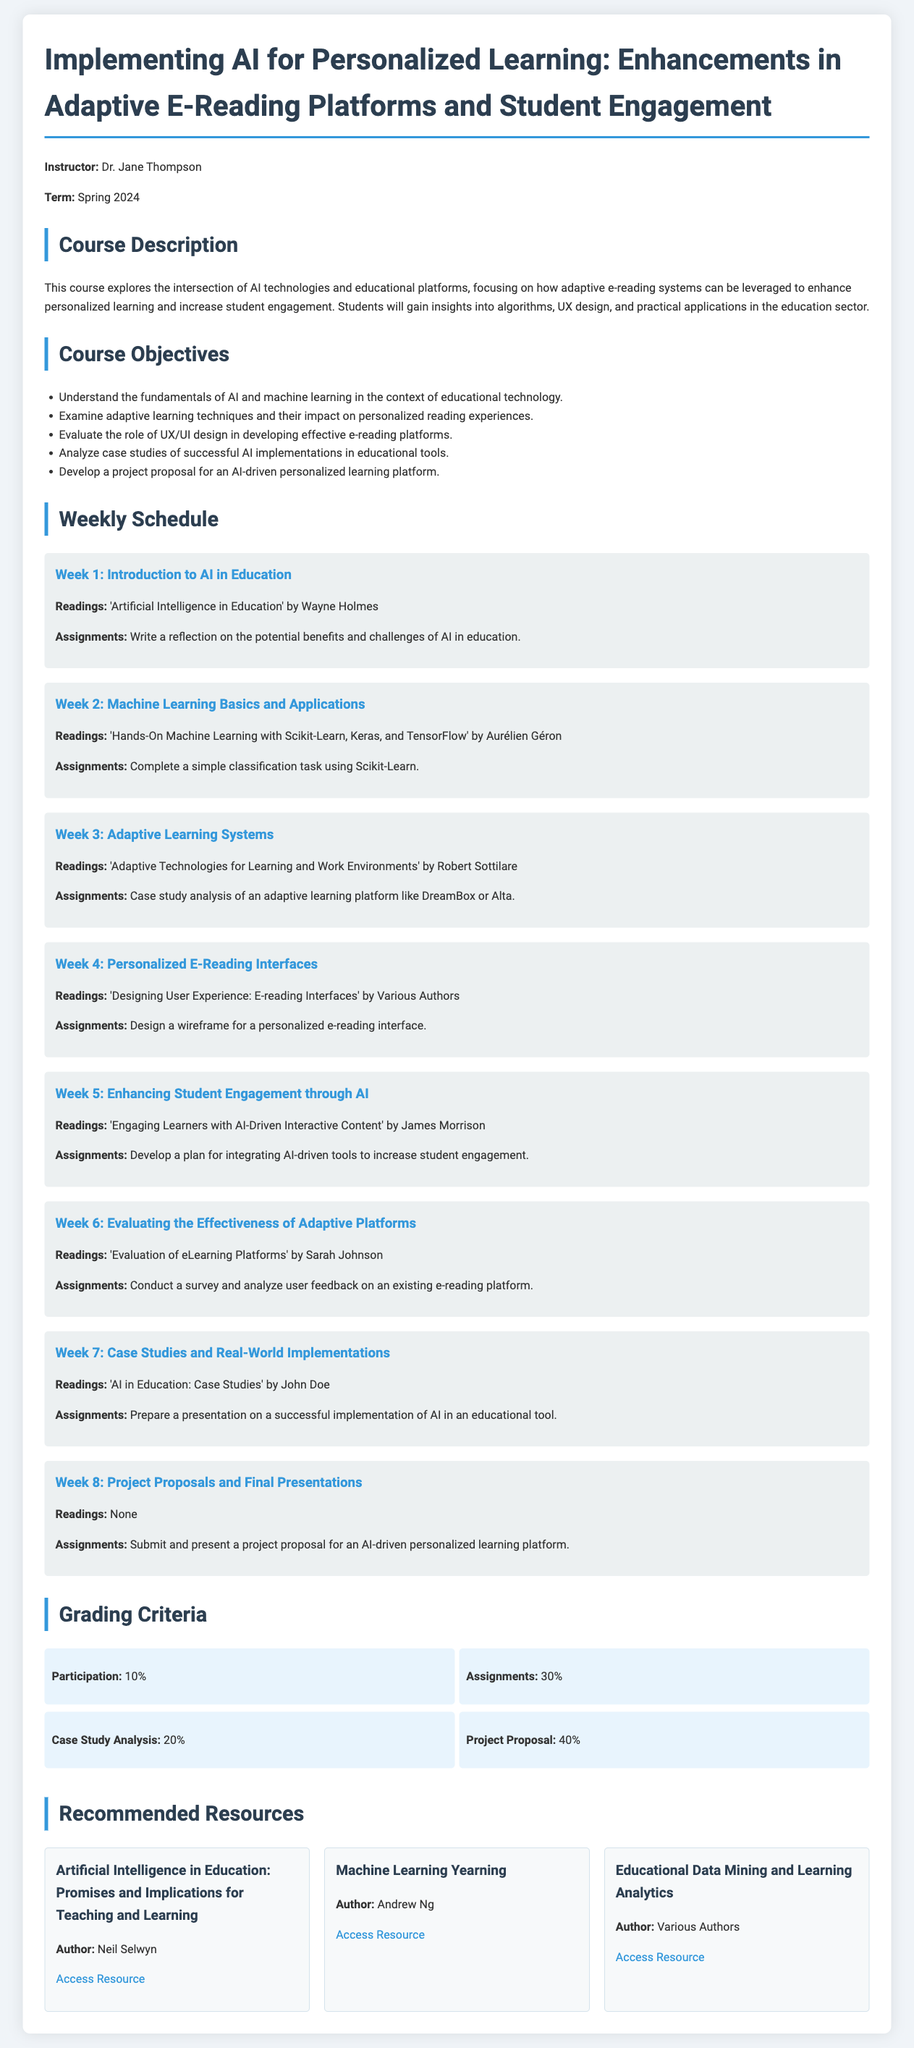What is the course title? The course title is stated at the beginning of the document, clearly indicating its focus on AI and personalized learning.
Answer: Implementing AI for Personalized Learning: Enhancements in Adaptive E-Reading Platforms and Student Engagement Who is the instructor for the course? The instructor's name is provided in the introductory section of the syllabus.
Answer: Dr. Jane Thompson What percentage of the grade is based on assignments? The grading criteria section mentions the percentage allocated for assignments.
Answer: 30% In which week is the topic of "Personalized E-Reading Interfaces" covered? The weekly schedule outlines the topics for each week, and week 4 is dedicated to this subject.
Answer: Week 4 What is one of the readings for Week 5? The readings for each week are listed under their respective weeks; Week 5 includes a specific title.
Answer: Engaging Learners with AI-Driven Interactive Content What is the primary focus of the course? The course description summarizes the main focus of the entire course.
Answer: Intersection of AI technologies and educational platforms Which week is dedicated to project proposals and final presentations? The weekly schedule details the specific focus of each week, with week 8 highlighting this aspect.
Answer: Week 8 How many case studies are analyzed in this course? The course objectives mention a specific task related to case studies in educational tools, but they do not specify a number.
Answer: One What is the name of the recommended resource by Andrew Ng? The recommended resources section lists various resources along with their authors.
Answer: Machine Learning Yearning 